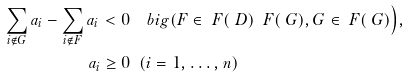Convert formula to latex. <formula><loc_0><loc_0><loc_500><loc_500>\sum _ { i \not \in G } a _ { i } - \sum _ { i \not \in F } a _ { i } < 0 & \quad b i g ( F \in \ F ( \ D ) \ \ F ( \ G ) , G \in \ F ( \ G ) \Big ) , \\ a _ { i } \geq 0 & \ \ ( i = 1 , \dots , n )</formula> 